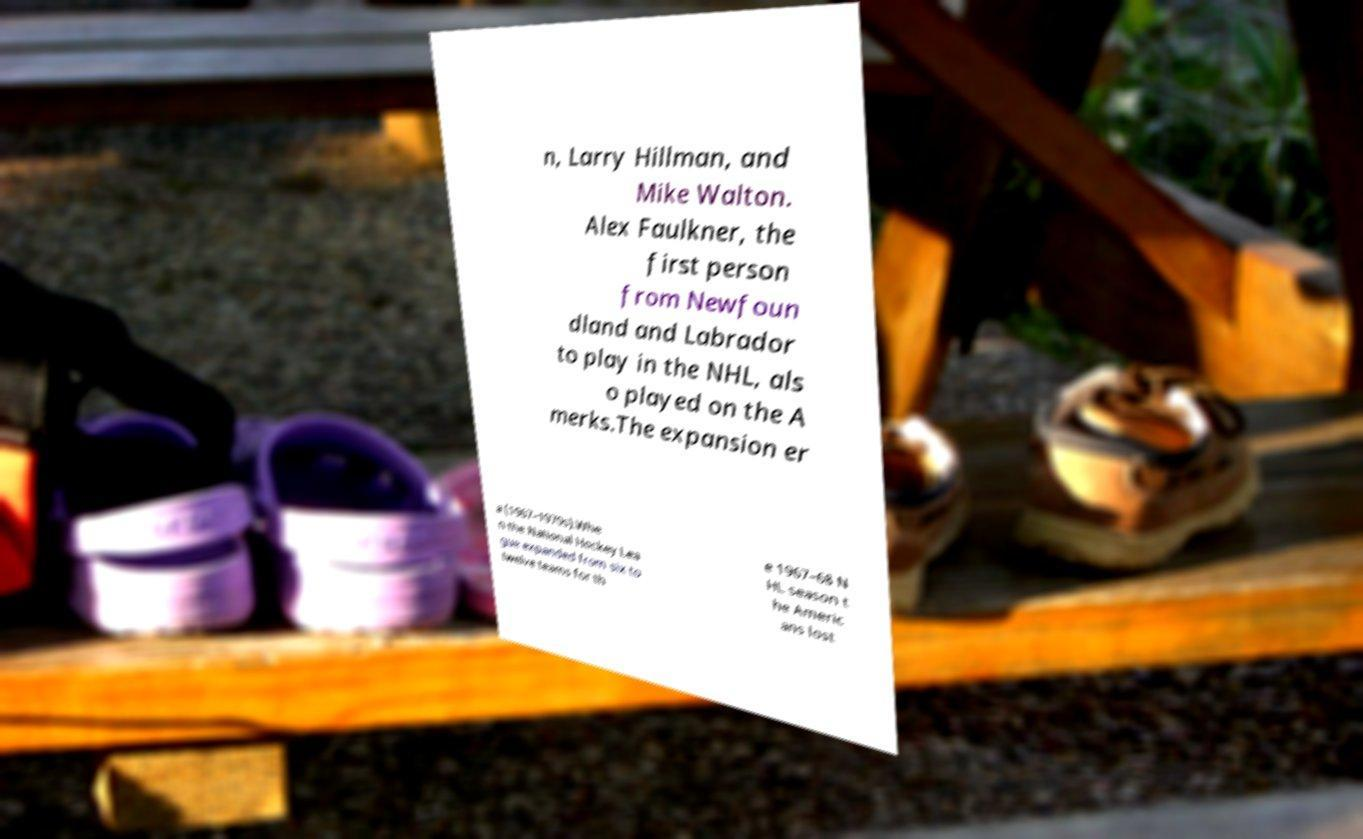What messages or text are displayed in this image? I need them in a readable, typed format. n, Larry Hillman, and Mike Walton. Alex Faulkner, the first person from Newfoun dland and Labrador to play in the NHL, als o played on the A merks.The expansion er a (1967–1970s).Whe n the National Hockey Lea gue expanded from six to twelve teams for th e 1967–68 N HL season t he Americ ans lost 